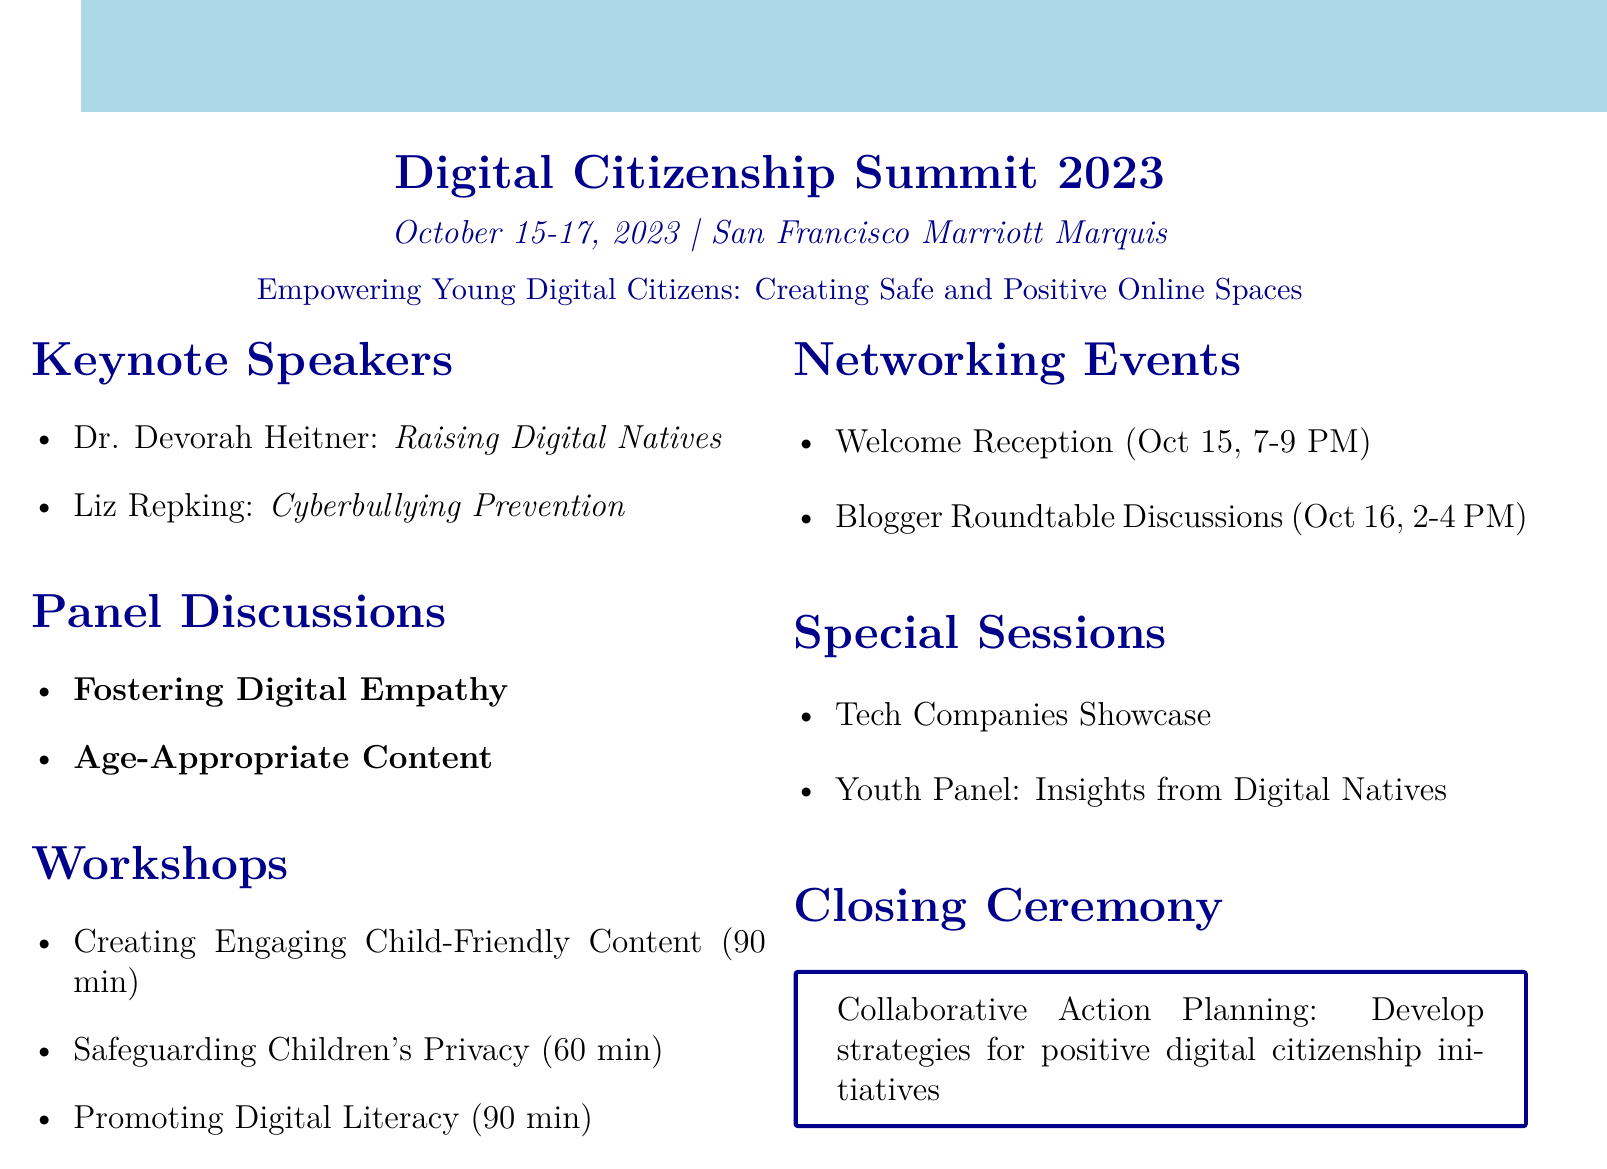What is the name of the event? The name of the event is stated at the top of the document.
Answer: Digital Citizenship Summit 2023 When is the event taking place? The date of the event is provided in the document.
Answer: October 15-17, 2023 Where is the event being held? The venue is mentioned clearly in the agenda.
Answer: San Francisco Marriott Marquis Who is presenting the workshop on creating engaging child-friendly content? The presenter for this workshop is listed in the workshop section.
Answer: Kristen Hewitt What topic does Dr. Devorah Heitner speak on? The topic for Dr. Devorah Heitner is indicated in the keynote speakers section.
Answer: Raising Digital Natives What is the duration of the workshop on safeguarding children's privacy? The duration is specified next to the workshop title.
Answer: 60 minutes What is one of the special sessions topics? The special sessions are mentioned in a dedicated section.
Answer: Tech Companies Showcase What is the focus of the closing ceremony? The description of the closing ceremony outlines its purpose.
Answer: Collaborative Action Planning How long is the blogger roundtable discussions scheduled for? The time frame for the roundtable discussions is given in the networking events section.
Answer: 2 hours 